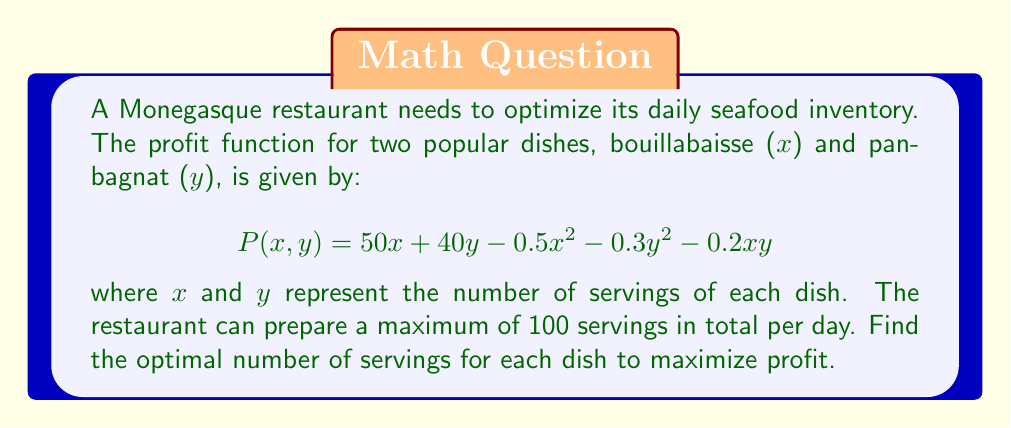Teach me how to tackle this problem. 1. Define the objective function:
   $$P(x,y) = 50x + 40y - 0.5x^2 - 0.3y^2 - 0.2xy$$

2. Define the constraint:
   $$x + y \leq 100$$
   $$x \geq 0, y \geq 0$$

3. Use the method of Lagrange multipliers:
   $$L(x,y,\lambda) = P(x,y) + \lambda(100 - x - y)$$

4. Calculate partial derivatives:
   $$\frac{\partial L}{\partial x} = 50 - x - 0.2y - \lambda = 0$$
   $$\frac{\partial L}{\partial y} = 40 - 0.6y - 0.2x - \lambda = 0$$
   $$\frac{\partial L}{\partial \lambda} = 100 - x - y = 0$$

5. Solve the system of equations:
   From (1) and (2):
   $$50 - x - 0.2y = 40 - 0.6y - 0.2x$$
   $$10 = 0.8x - 0.4y$$
   $$25 = 2x - y$$

   Substitute into (3):
   $$100 - x - (25 - 2x) = 0$$
   $$75 + x = 0$$
   $$x = 75$$

   Substitute back:
   $$y = 25$$

6. Verify second-order conditions for maximum:
   The Hessian matrix is negative definite, confirming a maximum.

7. Check the boundary conditions (x = 0, y = 0, x + y = 100):
   These yield lower profits than the interior solution.
Answer: 75 servings of bouillabaisse and 25 servings of pan-bagnat 